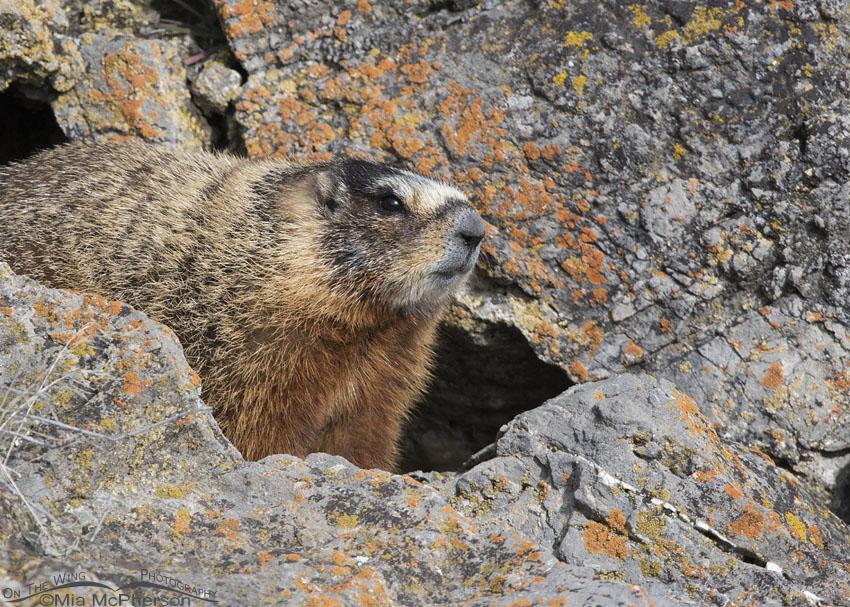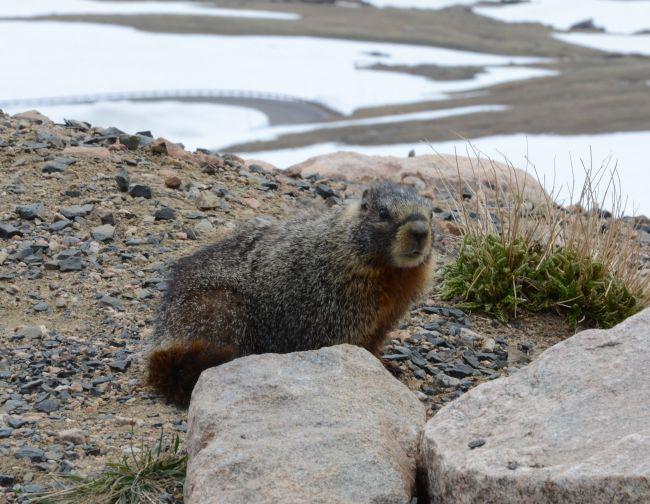The first image is the image on the left, the second image is the image on the right. Examine the images to the left and right. Is the description "The left image includes at least one marmot standing on its hind legs and clutching a piece of food near its mouth with both front paws." accurate? Answer yes or no. No. The first image is the image on the left, the second image is the image on the right. Analyze the images presented: Is the assertion "The left and right image contains the same number of groundhogs with at least one eating." valid? Answer yes or no. No. 